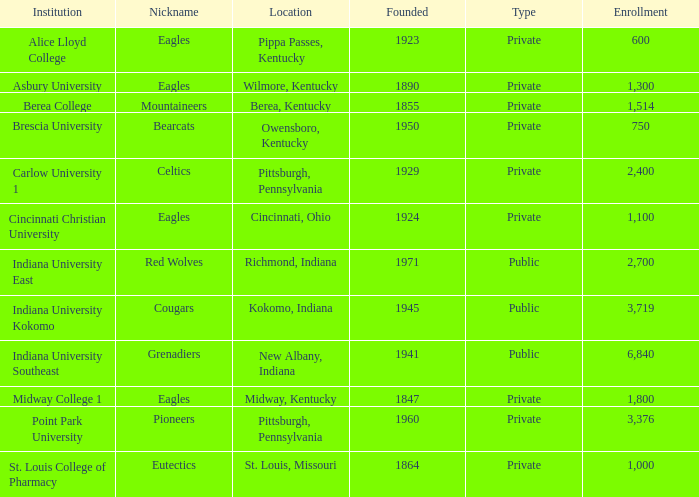Can you give me this table as a dict? {'header': ['Institution', 'Nickname', 'Location', 'Founded', 'Type', 'Enrollment'], 'rows': [['Alice Lloyd College', 'Eagles', 'Pippa Passes, Kentucky', '1923', 'Private', '600'], ['Asbury University', 'Eagles', 'Wilmore, Kentucky', '1890', 'Private', '1,300'], ['Berea College', 'Mountaineers', 'Berea, Kentucky', '1855', 'Private', '1,514'], ['Brescia University', 'Bearcats', 'Owensboro, Kentucky', '1950', 'Private', '750'], ['Carlow University 1', 'Celtics', 'Pittsburgh, Pennsylvania', '1929', 'Private', '2,400'], ['Cincinnati Christian University', 'Eagles', 'Cincinnati, Ohio', '1924', 'Private', '1,100'], ['Indiana University East', 'Red Wolves', 'Richmond, Indiana', '1971', 'Public', '2,700'], ['Indiana University Kokomo', 'Cougars', 'Kokomo, Indiana', '1945', 'Public', '3,719'], ['Indiana University Southeast', 'Grenadiers', 'New Albany, Indiana', '1941', 'Public', '6,840'], ['Midway College 1', 'Eagles', 'Midway, Kentucky', '1847', 'Private', '1,800'], ['Point Park University', 'Pioneers', 'Pittsburgh, Pennsylvania', '1960', 'Private', '3,376'], ['St. Louis College of Pharmacy', 'Eutectics', 'St. Louis, Missouri', '1864', 'Private', '1,000']]} Which public educational institution goes by the moniker the grenadiers? Indiana University Southeast. 